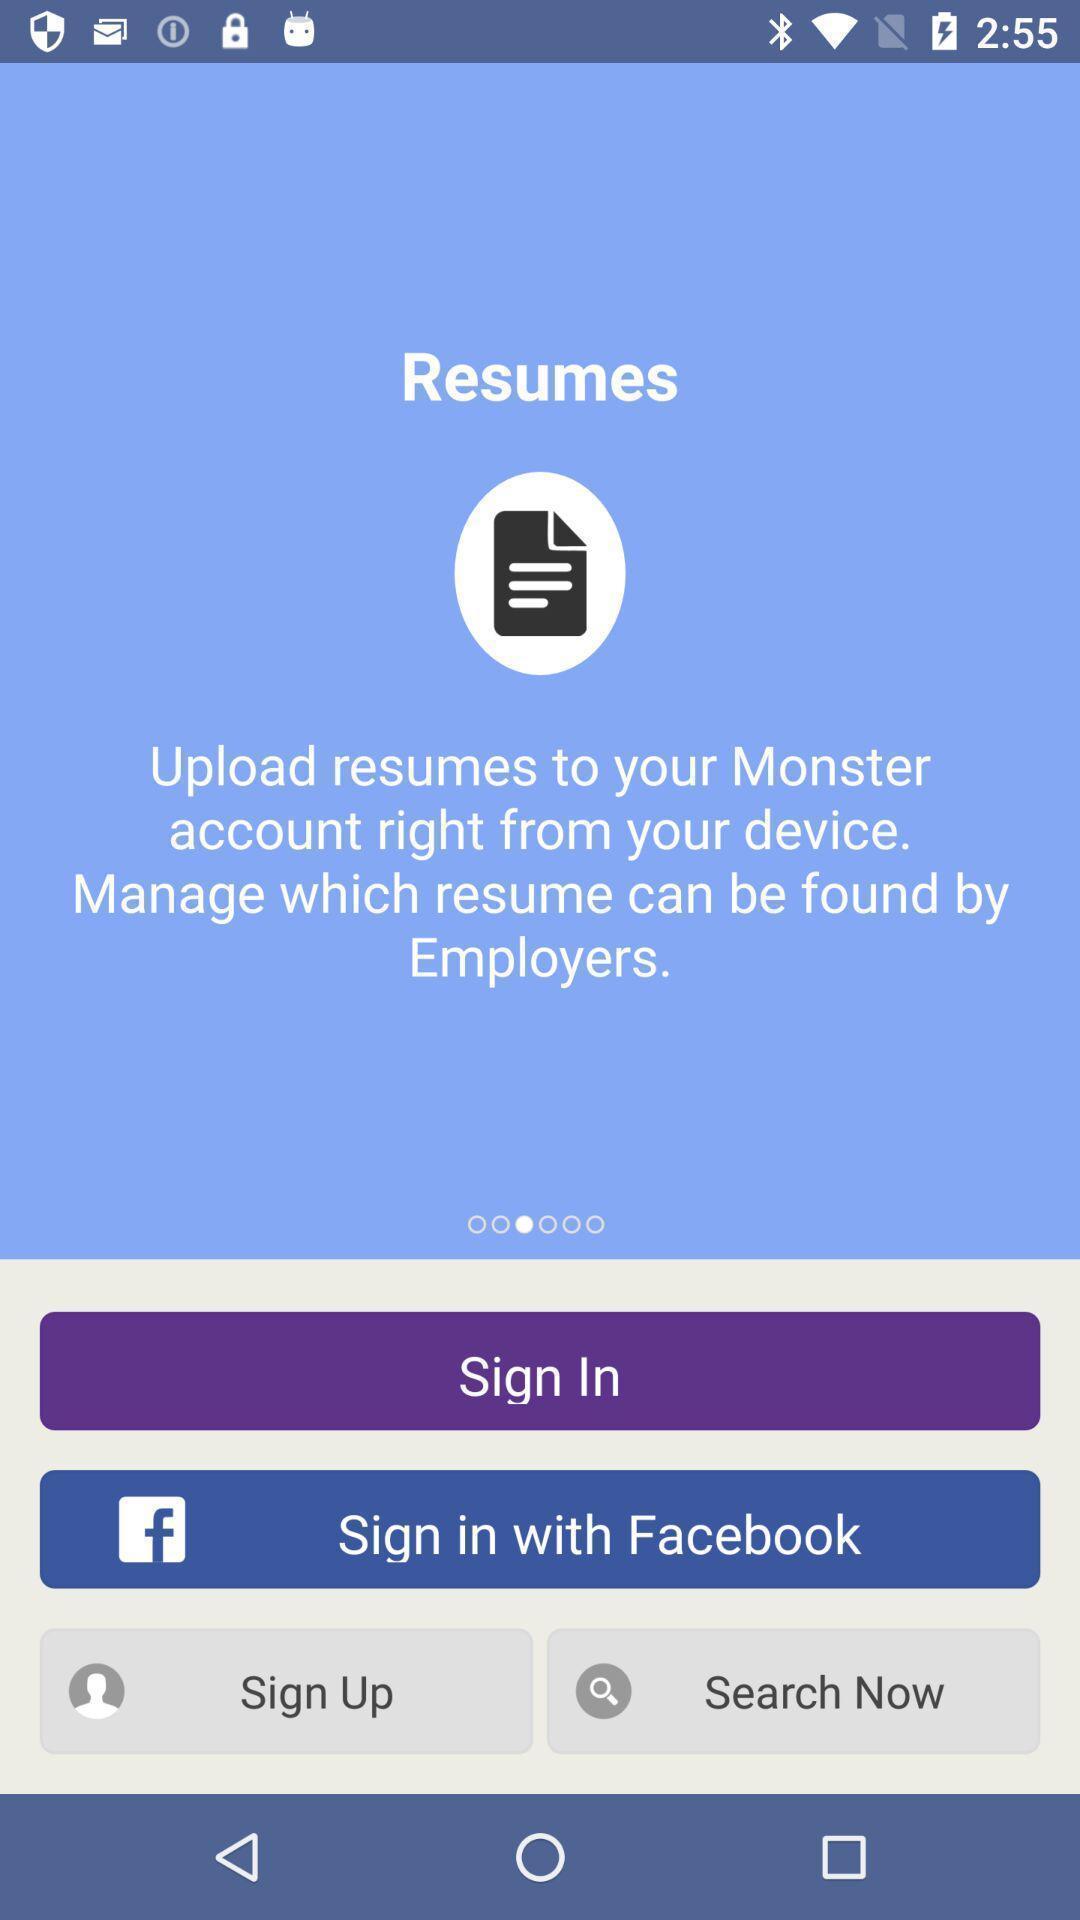Tell me what you see in this picture. Sign up page. 